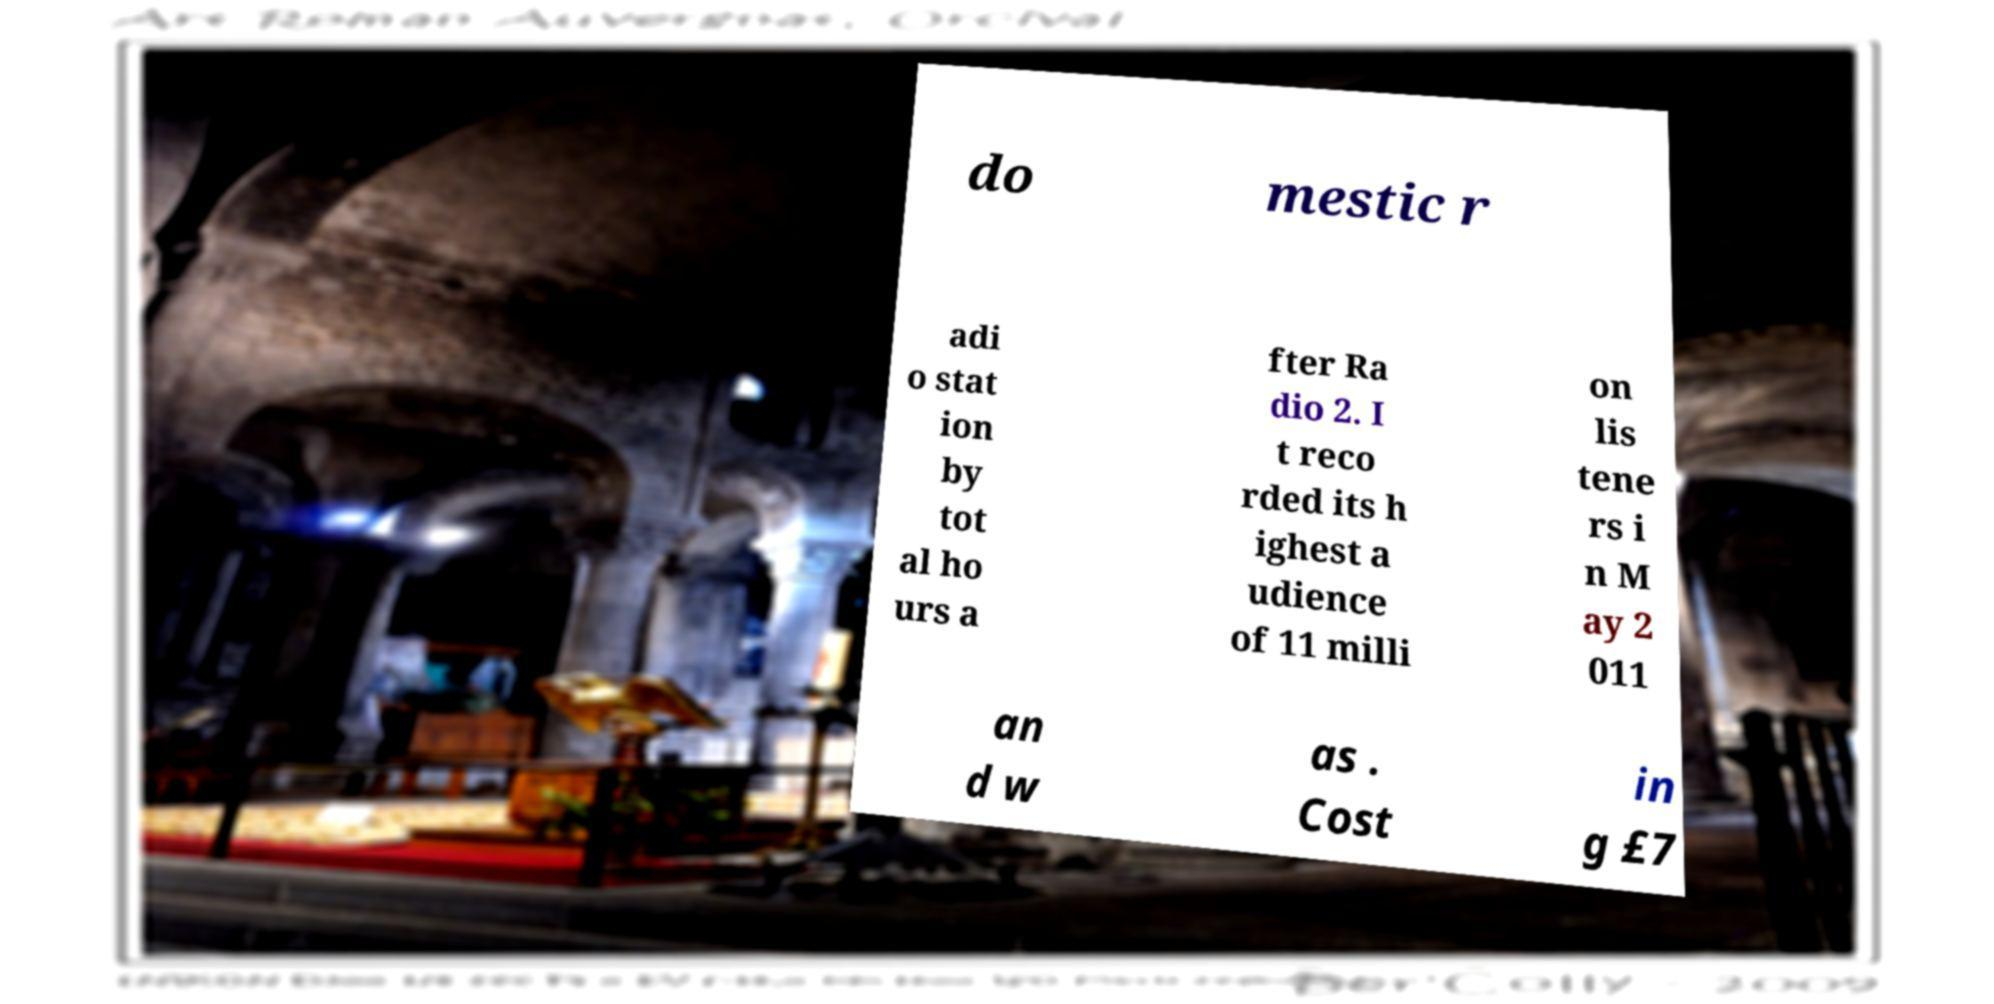Could you assist in decoding the text presented in this image and type it out clearly? do mestic r adi o stat ion by tot al ho urs a fter Ra dio 2. I t reco rded its h ighest a udience of 11 milli on lis tene rs i n M ay 2 011 an d w as . Cost in g £7 